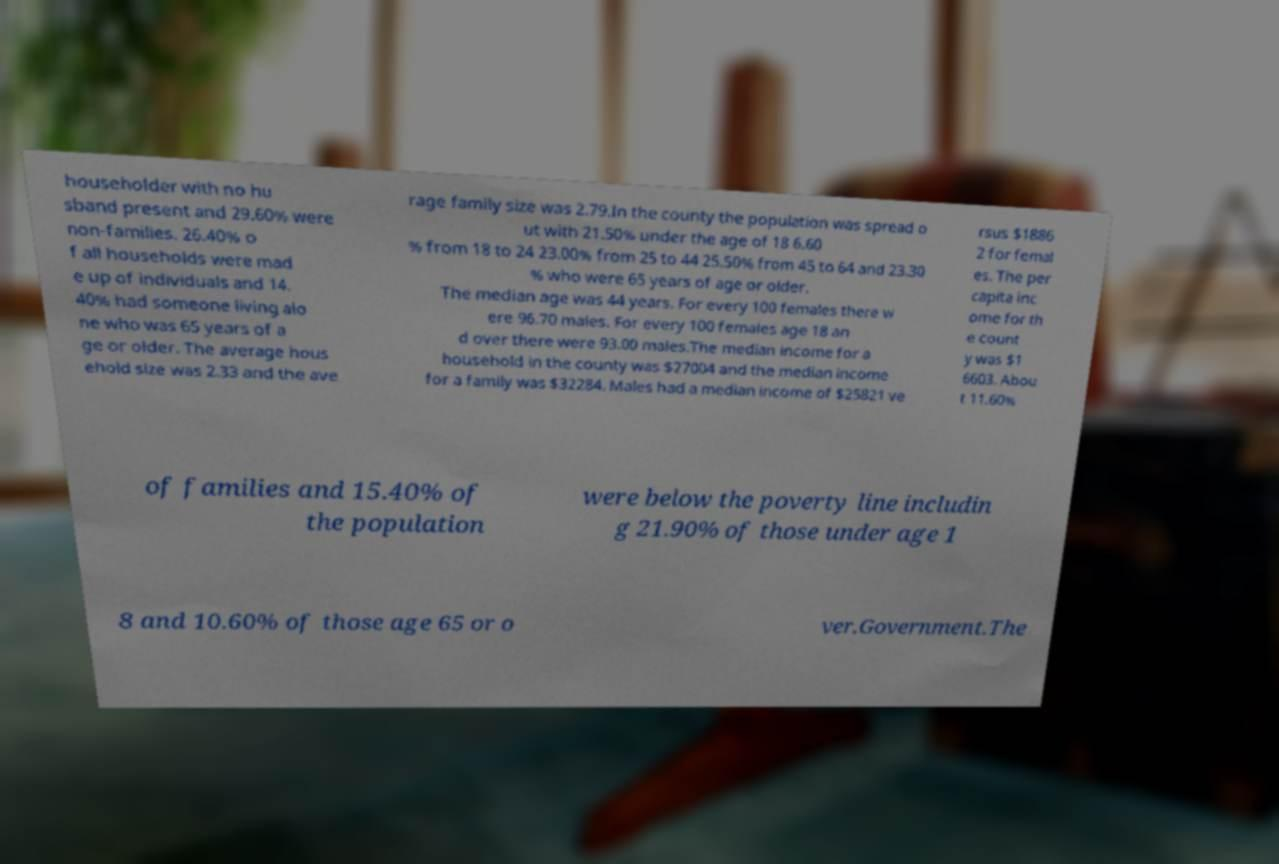Can you read and provide the text displayed in the image?This photo seems to have some interesting text. Can you extract and type it out for me? householder with no hu sband present and 29.60% were non-families. 26.40% o f all households were mad e up of individuals and 14. 40% had someone living alo ne who was 65 years of a ge or older. The average hous ehold size was 2.33 and the ave rage family size was 2.79.In the county the population was spread o ut with 21.50% under the age of 18 6.60 % from 18 to 24 23.00% from 25 to 44 25.50% from 45 to 64 and 23.30 % who were 65 years of age or older. The median age was 44 years. For every 100 females there w ere 96.70 males. For every 100 females age 18 an d over there were 93.00 males.The median income for a household in the county was $27004 and the median income for a family was $32284. Males had a median income of $25821 ve rsus $1886 2 for femal es. The per capita inc ome for th e count y was $1 6603. Abou t 11.60% of families and 15.40% of the population were below the poverty line includin g 21.90% of those under age 1 8 and 10.60% of those age 65 or o ver.Government.The 